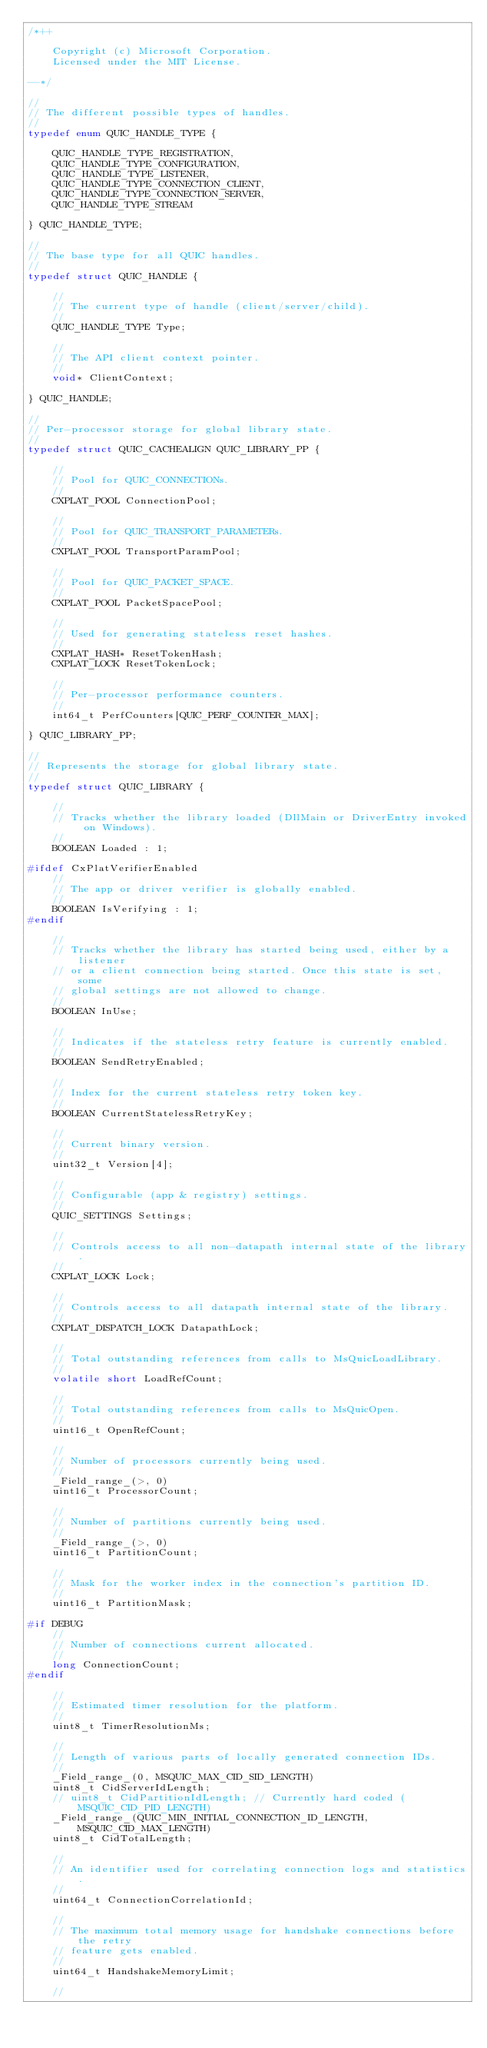<code> <loc_0><loc_0><loc_500><loc_500><_C_>/*++

    Copyright (c) Microsoft Corporation.
    Licensed under the MIT License.

--*/

//
// The different possible types of handles.
//
typedef enum QUIC_HANDLE_TYPE {

    QUIC_HANDLE_TYPE_REGISTRATION,
    QUIC_HANDLE_TYPE_CONFIGURATION,
    QUIC_HANDLE_TYPE_LISTENER,
    QUIC_HANDLE_TYPE_CONNECTION_CLIENT,
    QUIC_HANDLE_TYPE_CONNECTION_SERVER,
    QUIC_HANDLE_TYPE_STREAM

} QUIC_HANDLE_TYPE;

//
// The base type for all QUIC handles.
//
typedef struct QUIC_HANDLE {

    //
    // The current type of handle (client/server/child).
    //
    QUIC_HANDLE_TYPE Type;

    //
    // The API client context pointer.
    //
    void* ClientContext;

} QUIC_HANDLE;

//
// Per-processor storage for global library state.
//
typedef struct QUIC_CACHEALIGN QUIC_LIBRARY_PP {

    //
    // Pool for QUIC_CONNECTIONs.
    //
    CXPLAT_POOL ConnectionPool;

    //
    // Pool for QUIC_TRANSPORT_PARAMETERs.
    //
    CXPLAT_POOL TransportParamPool;

    //
    // Pool for QUIC_PACKET_SPACE.
    //
    CXPLAT_POOL PacketSpacePool;

    //
    // Used for generating stateless reset hashes.
    //
    CXPLAT_HASH* ResetTokenHash;
    CXPLAT_LOCK ResetTokenLock;

    //
    // Per-processor performance counters.
    //
    int64_t PerfCounters[QUIC_PERF_COUNTER_MAX];

} QUIC_LIBRARY_PP;

//
// Represents the storage for global library state.
//
typedef struct QUIC_LIBRARY {

    //
    // Tracks whether the library loaded (DllMain or DriverEntry invoked on Windows).
    //
    BOOLEAN Loaded : 1;

#ifdef CxPlatVerifierEnabled
    //
    // The app or driver verifier is globally enabled.
    //
    BOOLEAN IsVerifying : 1;
#endif

    //
    // Tracks whether the library has started being used, either by a listener
    // or a client connection being started. Once this state is set, some
    // global settings are not allowed to change.
    //
    BOOLEAN InUse;

    //
    // Indicates if the stateless retry feature is currently enabled.
    //
    BOOLEAN SendRetryEnabled;

    //
    // Index for the current stateless retry token key.
    //
    BOOLEAN CurrentStatelessRetryKey;

    //
    // Current binary version.
    //
    uint32_t Version[4];

    //
    // Configurable (app & registry) settings.
    //
    QUIC_SETTINGS Settings;

    //
    // Controls access to all non-datapath internal state of the library.
    //
    CXPLAT_LOCK Lock;

    //
    // Controls access to all datapath internal state of the library.
    //
    CXPLAT_DISPATCH_LOCK DatapathLock;

    //
    // Total outstanding references from calls to MsQuicLoadLibrary.
    //
    volatile short LoadRefCount;

    //
    // Total outstanding references from calls to MsQuicOpen.
    //
    uint16_t OpenRefCount;

    //
    // Number of processors currently being used.
    //
    _Field_range_(>, 0)
    uint16_t ProcessorCount;

    //
    // Number of partitions currently being used.
    //
    _Field_range_(>, 0)
    uint16_t PartitionCount;

    //
    // Mask for the worker index in the connection's partition ID.
    //
    uint16_t PartitionMask;

#if DEBUG
    //
    // Number of connections current allocated.
    //
    long ConnectionCount;
#endif

    //
    // Estimated timer resolution for the platform.
    //
    uint8_t TimerResolutionMs;

    //
    // Length of various parts of locally generated connection IDs.
    //
    _Field_range_(0, MSQUIC_MAX_CID_SID_LENGTH)
    uint8_t CidServerIdLength;
    // uint8_t CidPartitionIdLength; // Currently hard coded (MSQUIC_CID_PID_LENGTH)
    _Field_range_(QUIC_MIN_INITIAL_CONNECTION_ID_LENGTH, MSQUIC_CID_MAX_LENGTH)
    uint8_t CidTotalLength;

    //
    // An identifier used for correlating connection logs and statistics.
    //
    uint64_t ConnectionCorrelationId;

    //
    // The maximum total memory usage for handshake connections before the retry
    // feature gets enabled.
    //
    uint64_t HandshakeMemoryLimit;

    //</code> 